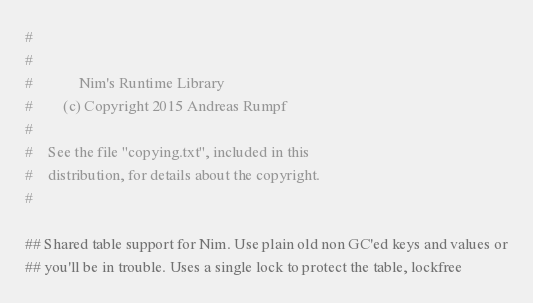<code> <loc_0><loc_0><loc_500><loc_500><_Nim_>#
#
#            Nim's Runtime Library
#        (c) Copyright 2015 Andreas Rumpf
#
#    See the file "copying.txt", included in this
#    distribution, for details about the copyright.
#

## Shared table support for Nim. Use plain old non GC'ed keys and values or
## you'll be in trouble. Uses a single lock to protect the table, lockfree</code> 